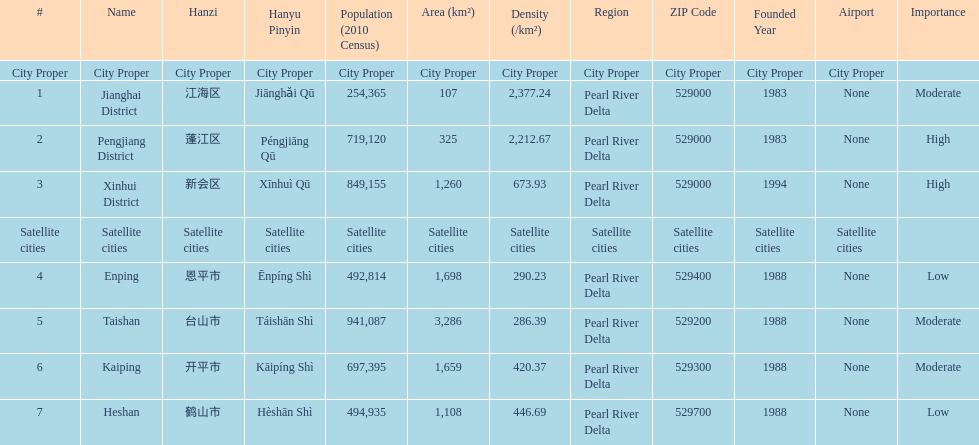Which area under the satellite cities has the most in population? Taishan. 